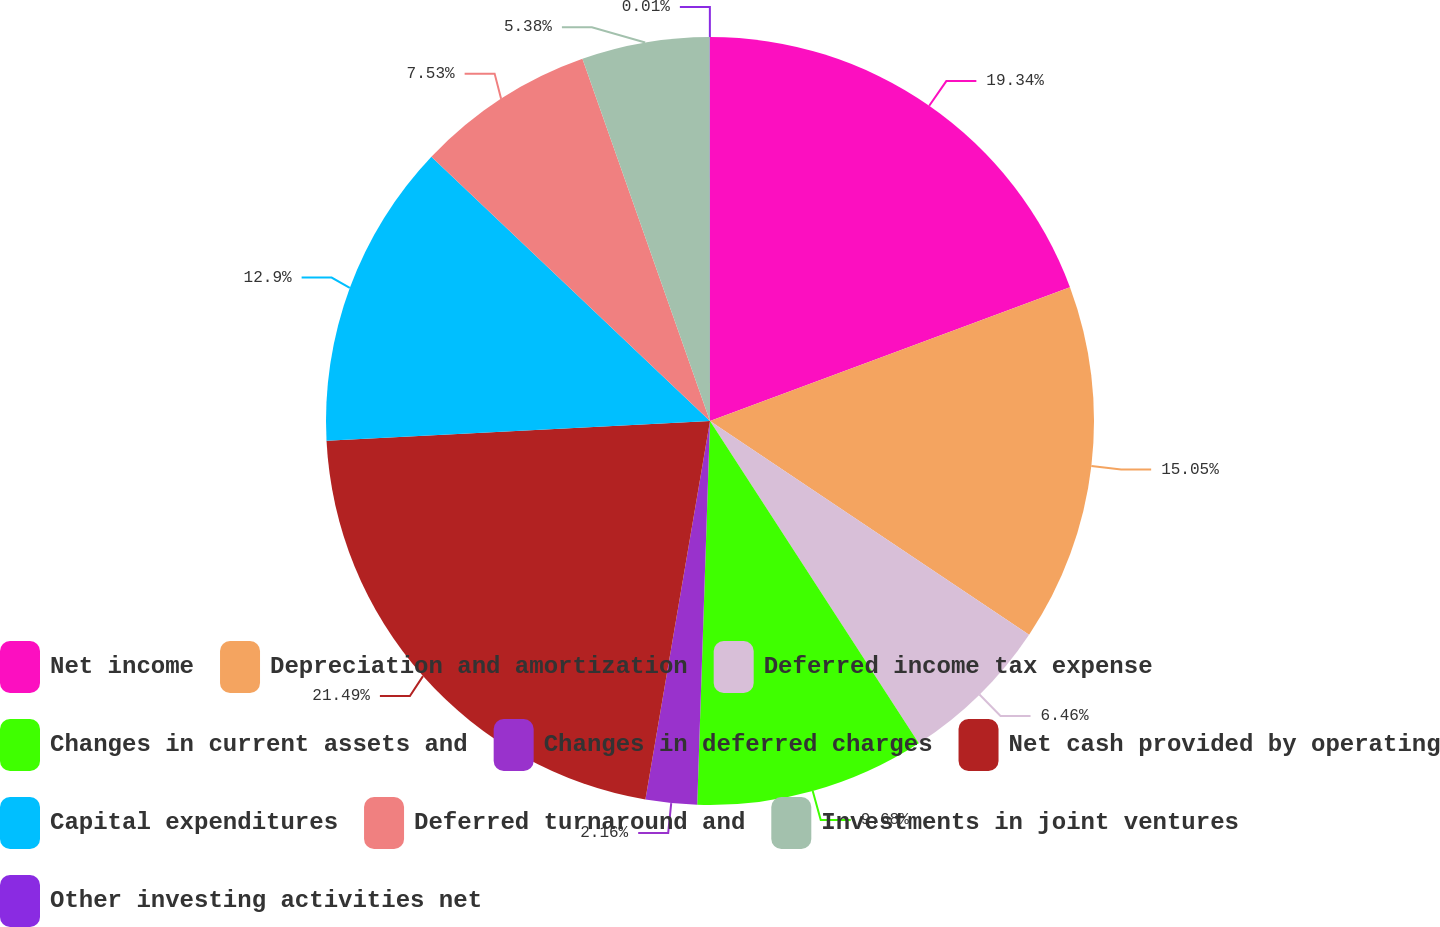Convert chart. <chart><loc_0><loc_0><loc_500><loc_500><pie_chart><fcel>Net income<fcel>Depreciation and amortization<fcel>Deferred income tax expense<fcel>Changes in current assets and<fcel>Changes in deferred charges<fcel>Net cash provided by operating<fcel>Capital expenditures<fcel>Deferred turnaround and<fcel>Investments in joint ventures<fcel>Other investing activities net<nl><fcel>19.34%<fcel>15.05%<fcel>6.46%<fcel>9.68%<fcel>2.16%<fcel>21.49%<fcel>12.9%<fcel>7.53%<fcel>5.38%<fcel>0.01%<nl></chart> 